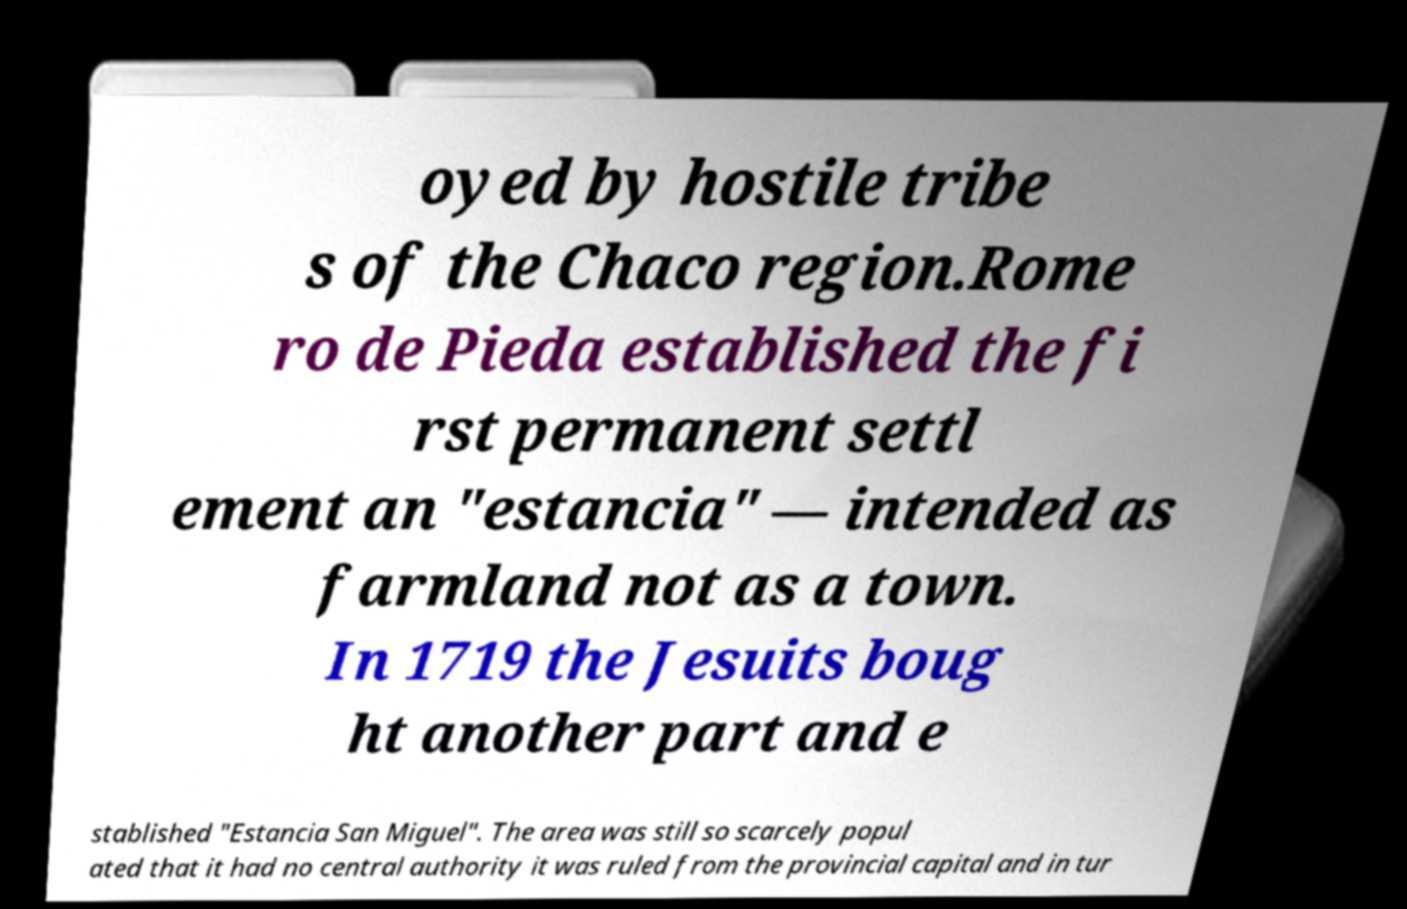Can you accurately transcribe the text from the provided image for me? oyed by hostile tribe s of the Chaco region.Rome ro de Pieda established the fi rst permanent settl ement an "estancia" — intended as farmland not as a town. In 1719 the Jesuits boug ht another part and e stablished "Estancia San Miguel". The area was still so scarcely popul ated that it had no central authority it was ruled from the provincial capital and in tur 